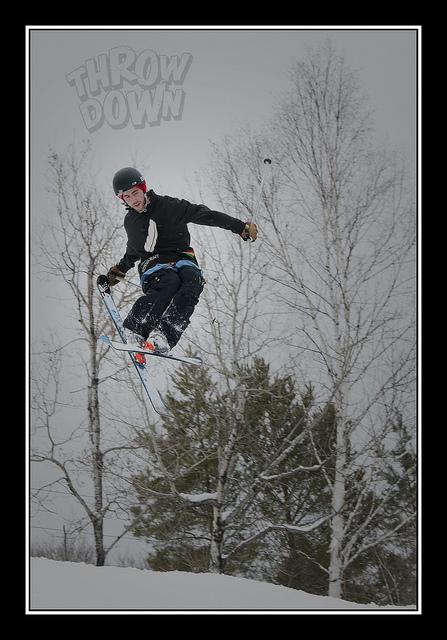Where is this person at?
Concise answer only. Ski resort. What is written above the skiers head?
Give a very brief answer. Throwdown. What color are his skis?
Be succinct. White. What two words describe the color of his ski pants?
Give a very brief answer. Black and blue. 